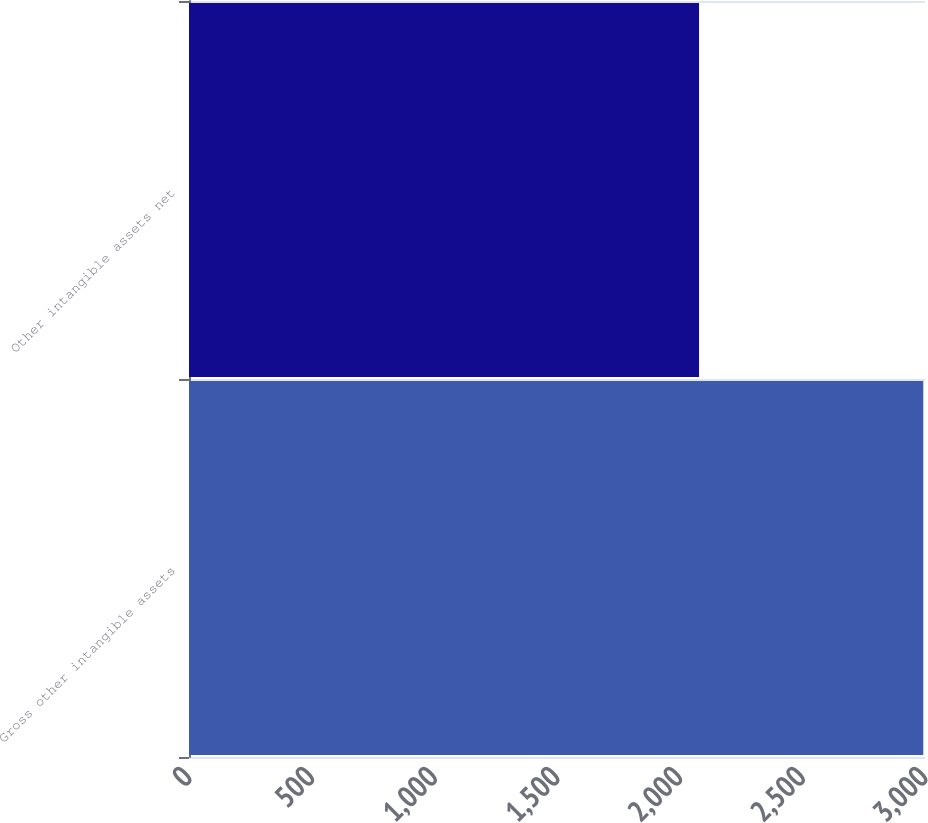Convert chart to OTSL. <chart><loc_0><loc_0><loc_500><loc_500><bar_chart><fcel>Gross other intangible assets<fcel>Other intangible assets net<nl><fcel>2993<fcel>2079<nl></chart> 